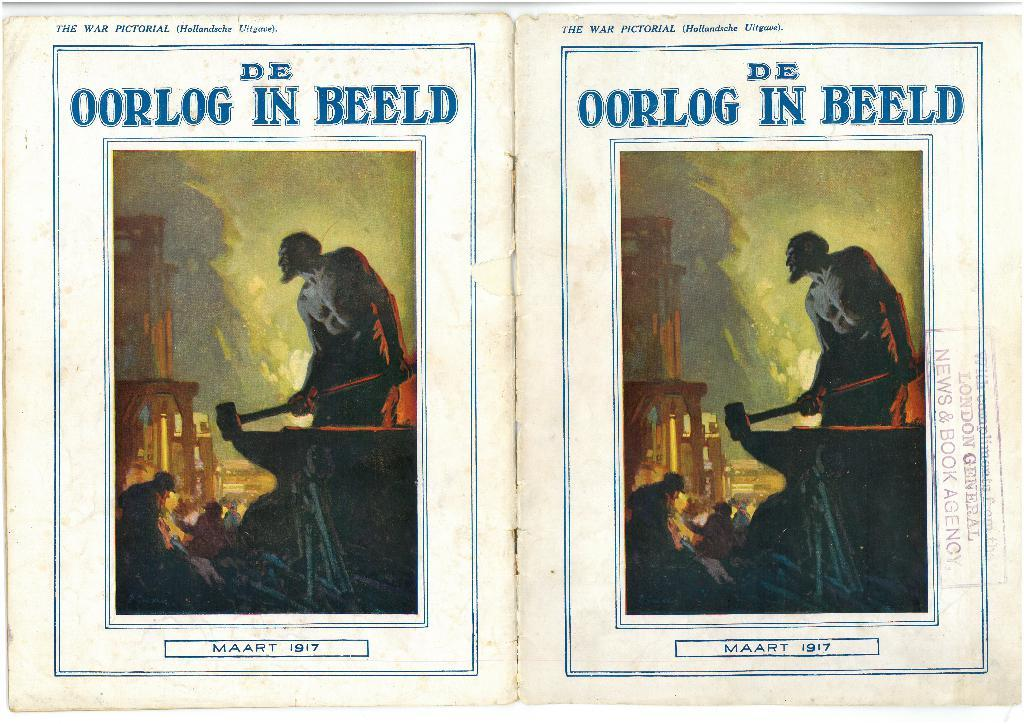<image>
Relay a brief, clear account of the picture shown. Two identical pages in The War Pictorial book. 